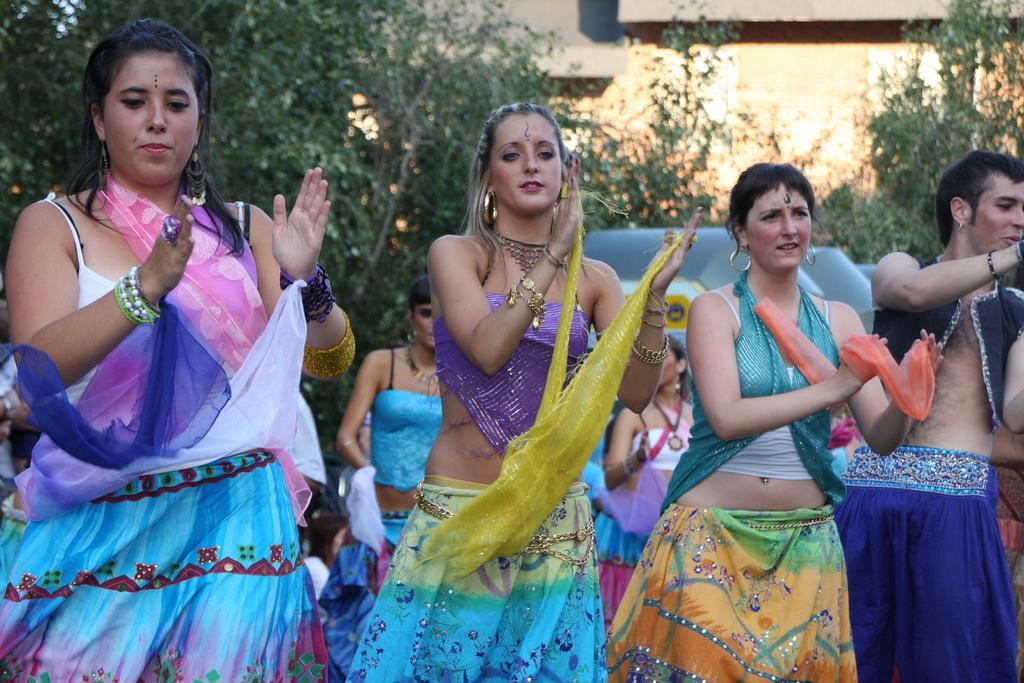How would you summarize this image in a sentence or two? In this image in front there are few people clapping. Behind them there are trees. At the back side there is a building. 